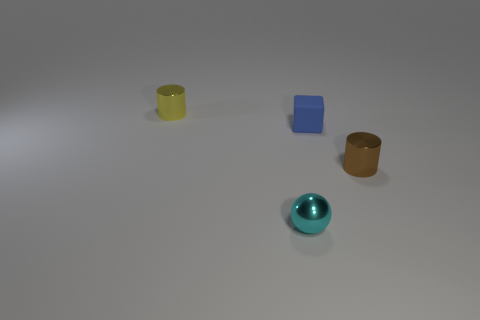Add 4 yellow cylinders. How many objects exist? 8 Subtract all brown cylinders. How many cylinders are left? 1 Subtract all blocks. How many objects are left? 3 Subtract 0 red spheres. How many objects are left? 4 Subtract 1 balls. How many balls are left? 0 Subtract all blue cylinders. Subtract all brown spheres. How many cylinders are left? 2 Subtract all large objects. Subtract all yellow cylinders. How many objects are left? 3 Add 3 shiny cylinders. How many shiny cylinders are left? 5 Add 4 small brown cylinders. How many small brown cylinders exist? 5 